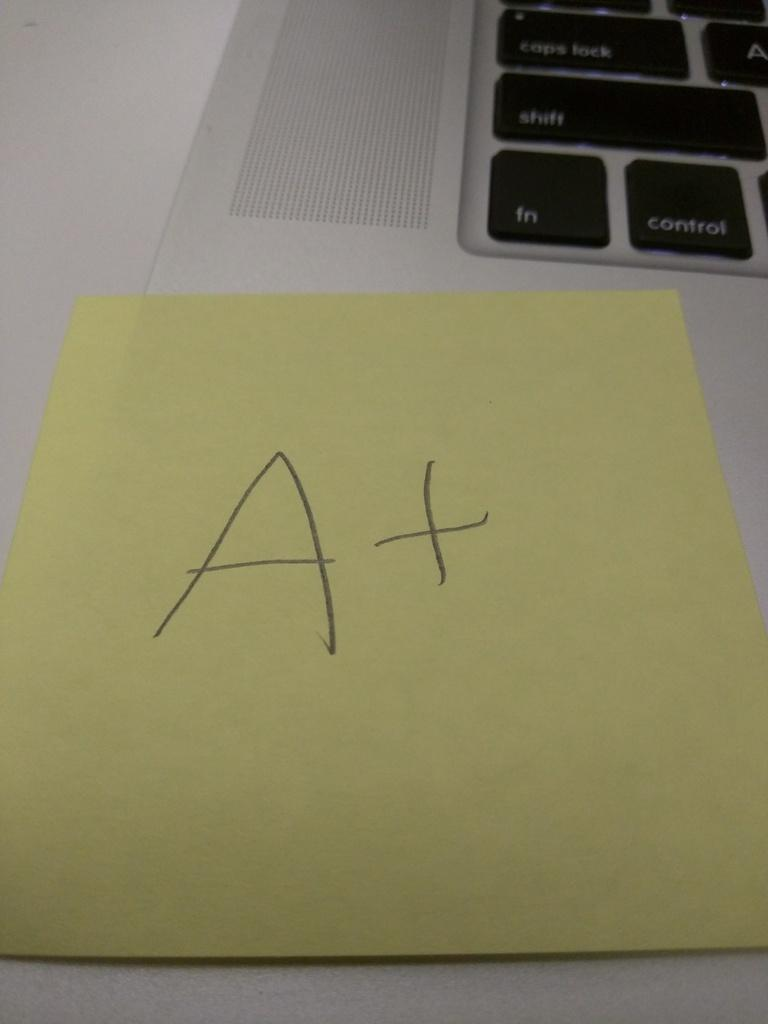<image>
Write a terse but informative summary of the picture. A yellow paper has a large A plus written on it. 